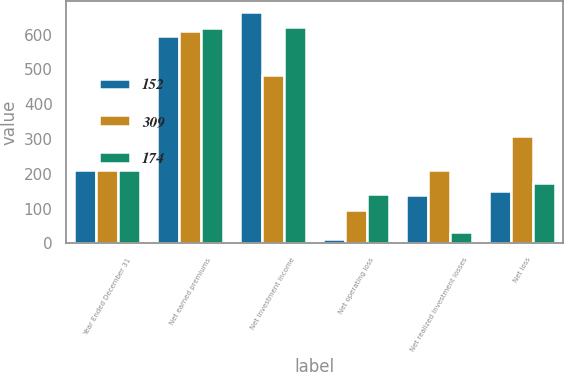Convert chart. <chart><loc_0><loc_0><loc_500><loc_500><stacked_bar_chart><ecel><fcel>Year Ended December 31<fcel>Net earned premiums<fcel>Net investment income<fcel>Net operating loss<fcel>Net realized investment losses<fcel>Net loss<nl><fcel>152<fcel>212<fcel>595<fcel>664<fcel>14<fcel>138<fcel>152<nl><fcel>309<fcel>212<fcel>612<fcel>484<fcel>97<fcel>212<fcel>309<nl><fcel>174<fcel>212<fcel>618<fcel>622<fcel>141<fcel>33<fcel>174<nl></chart> 